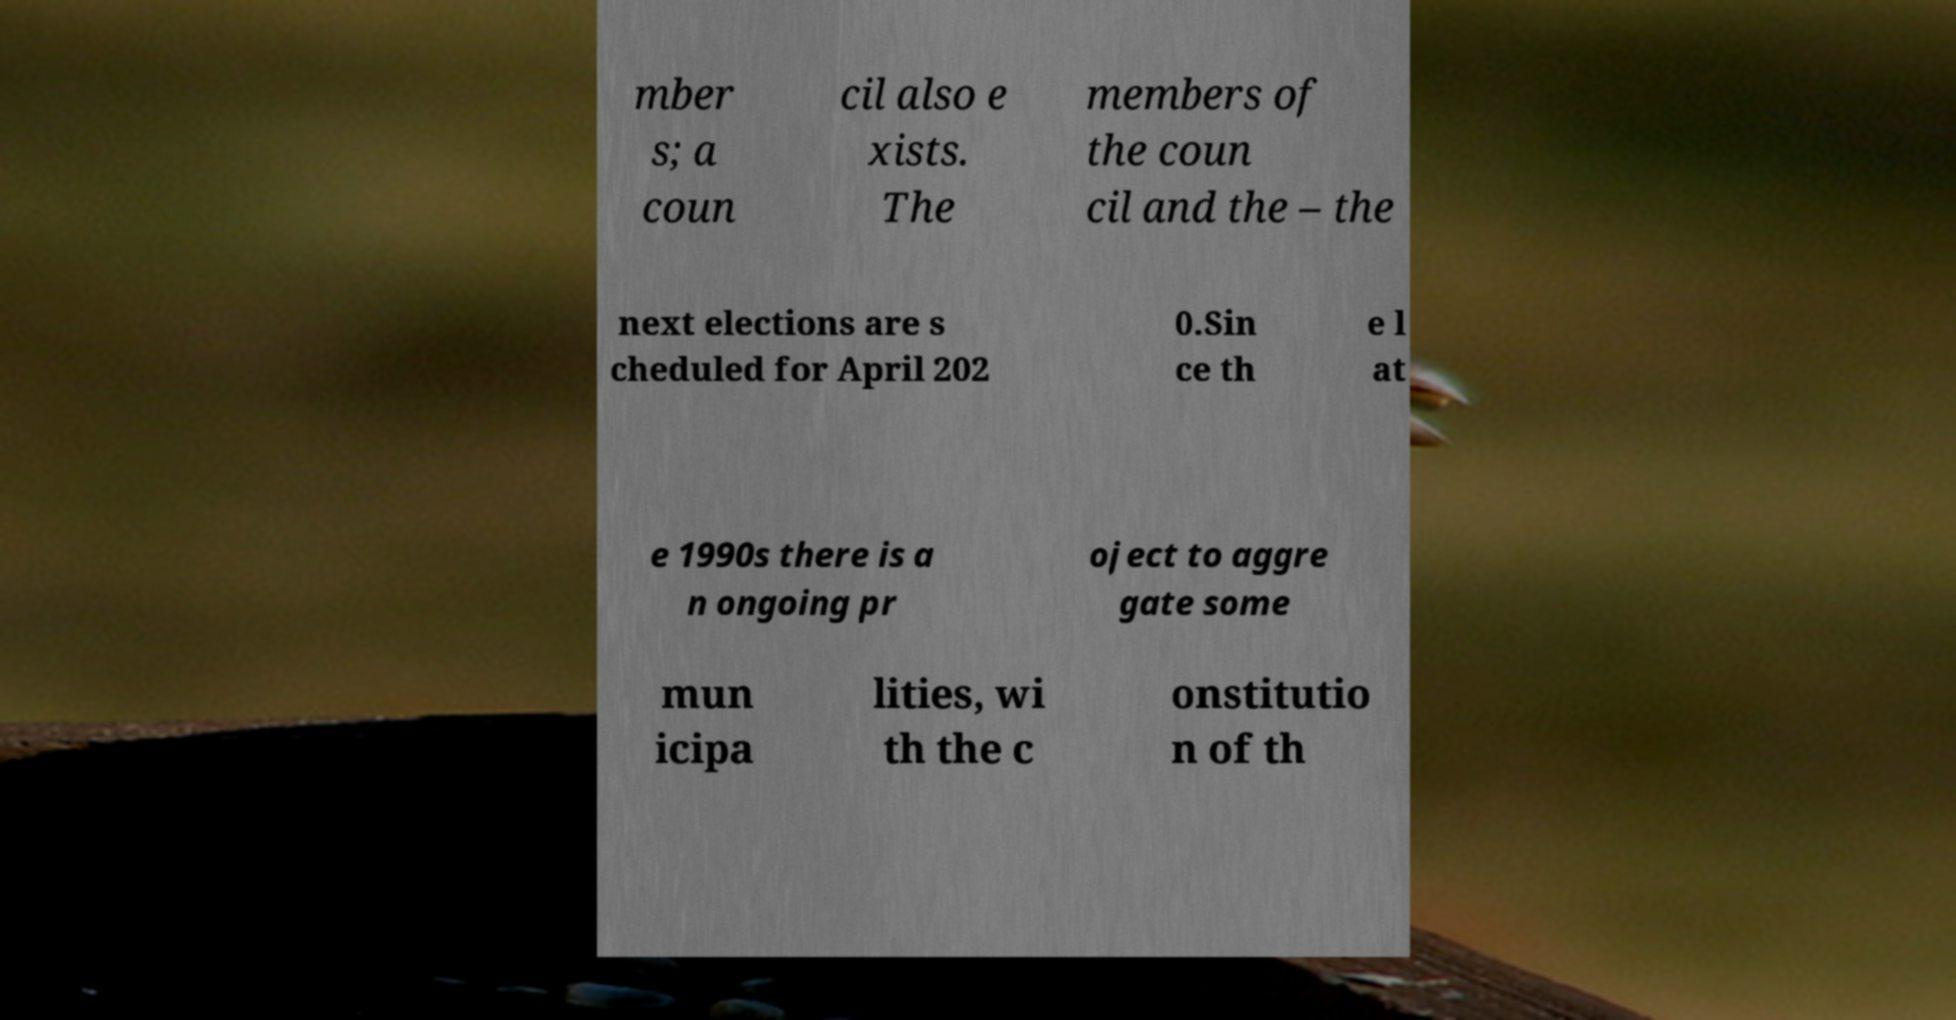Can you read and provide the text displayed in the image?This photo seems to have some interesting text. Can you extract and type it out for me? mber s; a coun cil also e xists. The members of the coun cil and the – the next elections are s cheduled for April 202 0.Sin ce th e l at e 1990s there is a n ongoing pr oject to aggre gate some mun icipa lities, wi th the c onstitutio n of th 